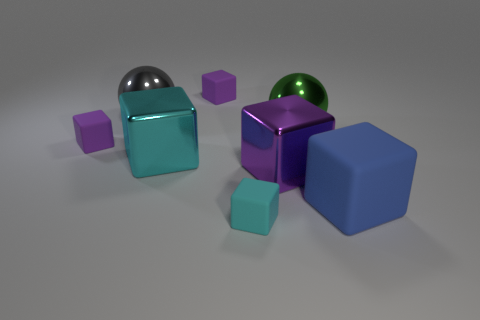There is a cyan cube behind the big blue cube; does it have the same size as the block behind the big green object?
Provide a short and direct response. No. Does the cyan metal block have the same size as the cyan matte cube?
Your answer should be compact. No. Is the number of small purple blocks that are left of the cyan metallic object less than the number of big blocks?
Offer a terse response. Yes. There is a tiny rubber thing that is behind the small rubber cube that is left of the gray metal thing; what is its color?
Your response must be concise. Purple. There is a purple block behind the metallic sphere on the left side of the cyan cube that is behind the blue block; how big is it?
Your answer should be very brief. Small. Is the number of large matte blocks in front of the cyan rubber thing less than the number of objects behind the large blue cube?
Provide a succinct answer. Yes. What number of big gray spheres are the same material as the tiny cyan cube?
Offer a terse response. 0. There is a big shiny ball left of the object that is behind the large gray metallic sphere; are there any tiny rubber blocks behind it?
Provide a short and direct response. Yes. What shape is the large green object that is the same material as the big gray ball?
Your answer should be very brief. Sphere. Is the number of small metal blocks greater than the number of tiny matte things?
Provide a short and direct response. No. 